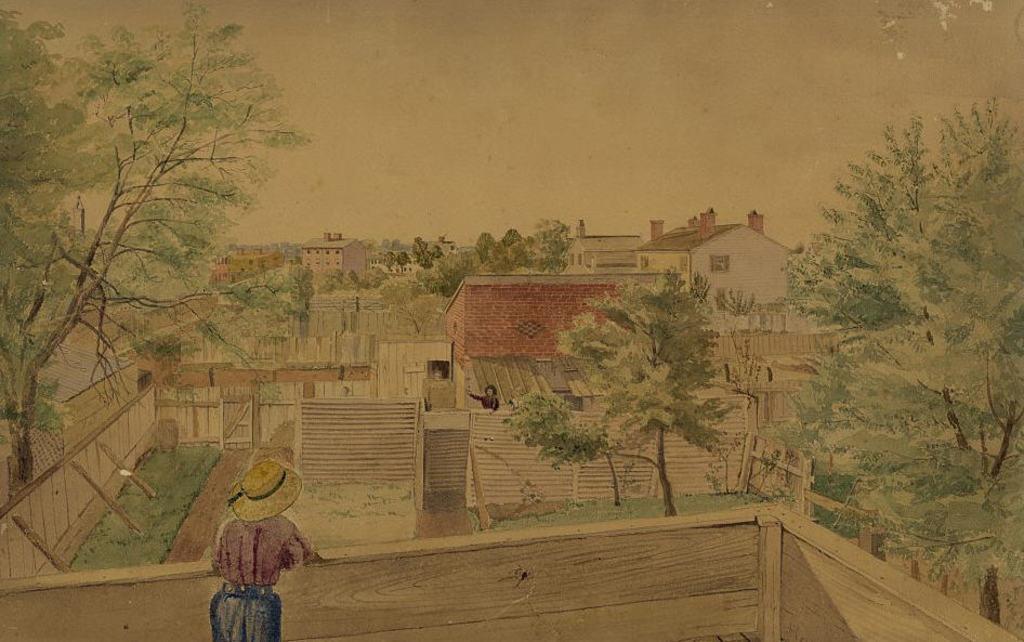Can you describe this image briefly? In this image I can see the painting in which I can see few persons are standing on the buildings. I can see few stairs, few trees which are green in color and few buildings. In the background I can see the sky. 